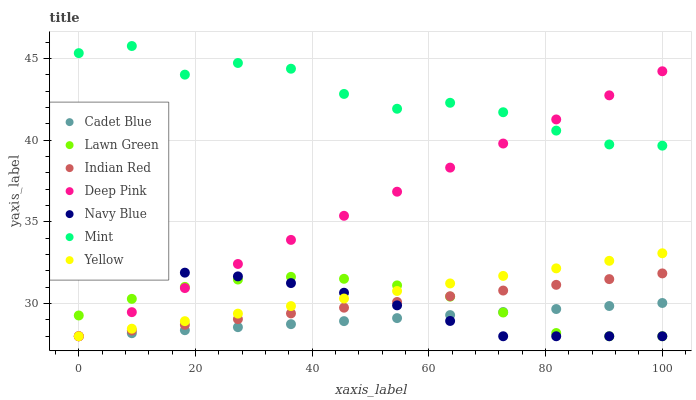Does Cadet Blue have the minimum area under the curve?
Answer yes or no. Yes. Does Mint have the maximum area under the curve?
Answer yes or no. Yes. Does Navy Blue have the minimum area under the curve?
Answer yes or no. No. Does Navy Blue have the maximum area under the curve?
Answer yes or no. No. Is Deep Pink the smoothest?
Answer yes or no. Yes. Is Mint the roughest?
Answer yes or no. Yes. Is Cadet Blue the smoothest?
Answer yes or no. No. Is Cadet Blue the roughest?
Answer yes or no. No. Does Lawn Green have the lowest value?
Answer yes or no. Yes. Does Mint have the lowest value?
Answer yes or no. No. Does Mint have the highest value?
Answer yes or no. Yes. Does Navy Blue have the highest value?
Answer yes or no. No. Is Lawn Green less than Mint?
Answer yes or no. Yes. Is Mint greater than Indian Red?
Answer yes or no. Yes. Does Navy Blue intersect Yellow?
Answer yes or no. Yes. Is Navy Blue less than Yellow?
Answer yes or no. No. Is Navy Blue greater than Yellow?
Answer yes or no. No. Does Lawn Green intersect Mint?
Answer yes or no. No. 